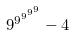<formula> <loc_0><loc_0><loc_500><loc_500>9 ^ { 9 ^ { 9 ^ { 9 ^ { 9 } } } } - 4</formula> 